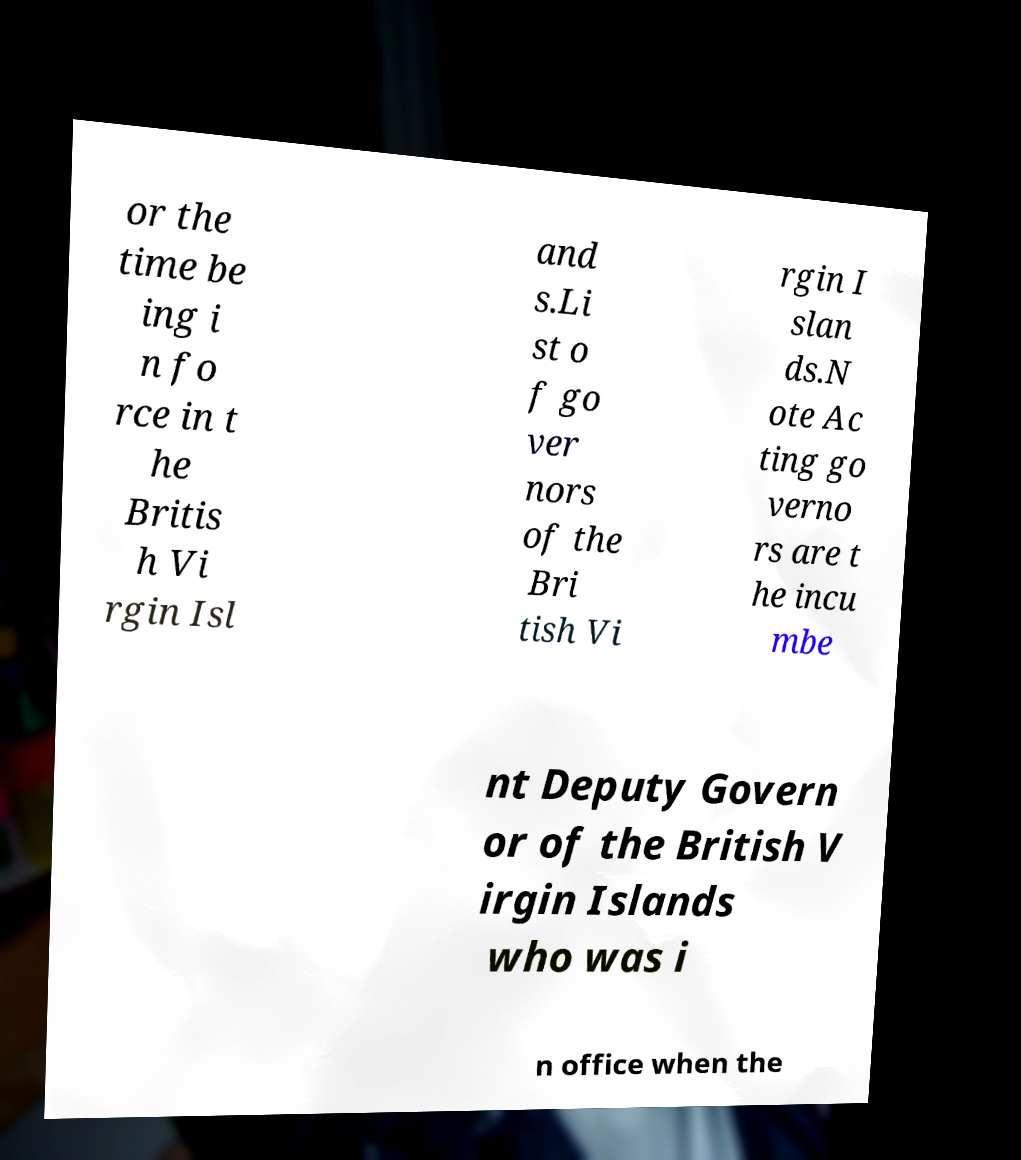Can you accurately transcribe the text from the provided image for me? or the time be ing i n fo rce in t he Britis h Vi rgin Isl and s.Li st o f go ver nors of the Bri tish Vi rgin I slan ds.N ote Ac ting go verno rs are t he incu mbe nt Deputy Govern or of the British V irgin Islands who was i n office when the 